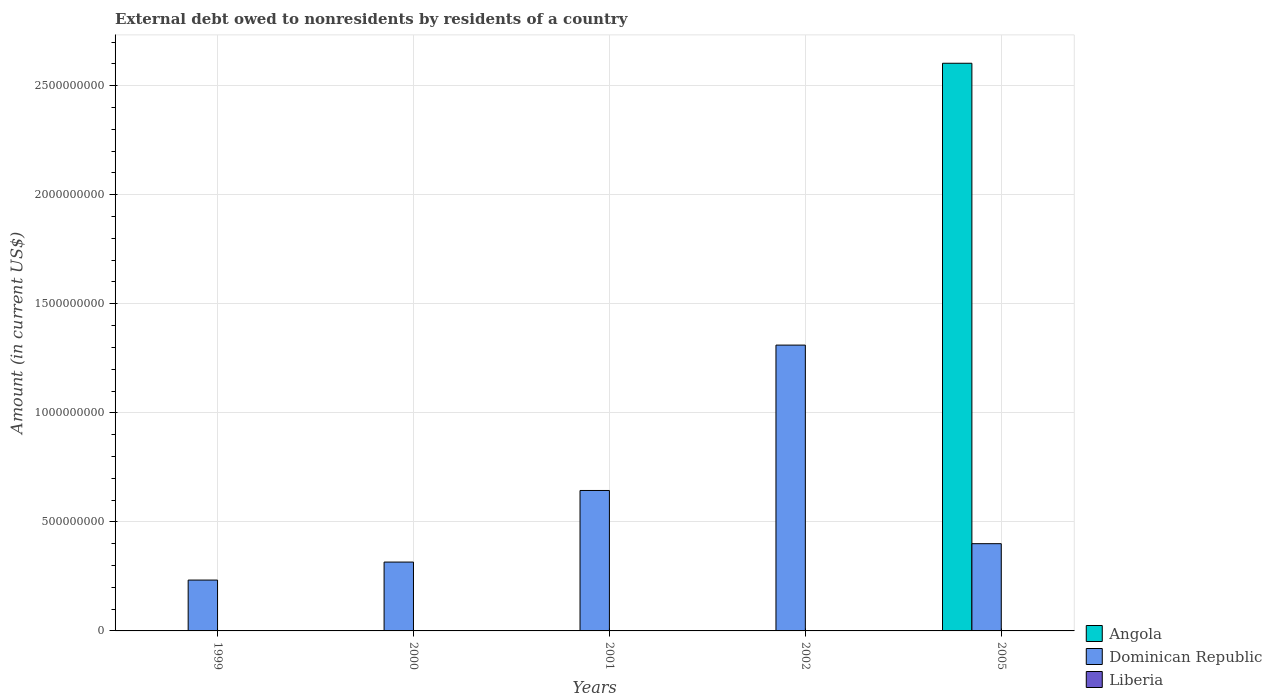How many different coloured bars are there?
Ensure brevity in your answer.  2. Are the number of bars per tick equal to the number of legend labels?
Your response must be concise. No. How many bars are there on the 5th tick from the right?
Ensure brevity in your answer.  1. In how many cases, is the number of bars for a given year not equal to the number of legend labels?
Provide a short and direct response. 5. What is the external debt owed by residents in Dominican Republic in 2005?
Your answer should be compact. 4.00e+08. Across all years, what is the maximum external debt owed by residents in Angola?
Provide a succinct answer. 2.60e+09. In which year was the external debt owed by residents in Angola maximum?
Ensure brevity in your answer.  2005. What is the total external debt owed by residents in Dominican Republic in the graph?
Offer a terse response. 2.90e+09. What is the difference between the external debt owed by residents in Dominican Republic in 1999 and that in 2000?
Give a very brief answer. -8.25e+07. What is the difference between the external debt owed by residents in Liberia in 2002 and the external debt owed by residents in Dominican Republic in 1999?
Provide a succinct answer. -2.33e+08. What is the average external debt owed by residents in Angola per year?
Your answer should be compact. 5.21e+08. In the year 2005, what is the difference between the external debt owed by residents in Dominican Republic and external debt owed by residents in Angola?
Your response must be concise. -2.20e+09. What is the ratio of the external debt owed by residents in Dominican Republic in 2000 to that in 2005?
Offer a very short reply. 0.79. What is the difference between the highest and the second highest external debt owed by residents in Dominican Republic?
Give a very brief answer. 6.67e+08. What is the difference between the highest and the lowest external debt owed by residents in Dominican Republic?
Offer a terse response. 1.08e+09. Is the sum of the external debt owed by residents in Dominican Republic in 1999 and 2002 greater than the maximum external debt owed by residents in Liberia across all years?
Ensure brevity in your answer.  Yes. Are all the bars in the graph horizontal?
Your answer should be compact. No. How many years are there in the graph?
Your response must be concise. 5. Does the graph contain grids?
Keep it short and to the point. Yes. Where does the legend appear in the graph?
Give a very brief answer. Bottom right. What is the title of the graph?
Ensure brevity in your answer.  External debt owed to nonresidents by residents of a country. What is the label or title of the X-axis?
Your response must be concise. Years. What is the label or title of the Y-axis?
Give a very brief answer. Amount (in current US$). What is the Amount (in current US$) in Angola in 1999?
Offer a very short reply. 0. What is the Amount (in current US$) of Dominican Republic in 1999?
Keep it short and to the point. 2.33e+08. What is the Amount (in current US$) in Liberia in 1999?
Make the answer very short. 0. What is the Amount (in current US$) of Dominican Republic in 2000?
Your response must be concise. 3.16e+08. What is the Amount (in current US$) of Liberia in 2000?
Your answer should be compact. 0. What is the Amount (in current US$) of Dominican Republic in 2001?
Make the answer very short. 6.44e+08. What is the Amount (in current US$) in Liberia in 2001?
Your answer should be compact. 0. What is the Amount (in current US$) in Angola in 2002?
Keep it short and to the point. 0. What is the Amount (in current US$) in Dominican Republic in 2002?
Your response must be concise. 1.31e+09. What is the Amount (in current US$) in Liberia in 2002?
Keep it short and to the point. 0. What is the Amount (in current US$) of Angola in 2005?
Keep it short and to the point. 2.60e+09. What is the Amount (in current US$) of Dominican Republic in 2005?
Offer a terse response. 4.00e+08. Across all years, what is the maximum Amount (in current US$) in Angola?
Your response must be concise. 2.60e+09. Across all years, what is the maximum Amount (in current US$) of Dominican Republic?
Offer a terse response. 1.31e+09. Across all years, what is the minimum Amount (in current US$) of Dominican Republic?
Keep it short and to the point. 2.33e+08. What is the total Amount (in current US$) of Angola in the graph?
Provide a succinct answer. 2.60e+09. What is the total Amount (in current US$) of Dominican Republic in the graph?
Make the answer very short. 2.90e+09. What is the difference between the Amount (in current US$) of Dominican Republic in 1999 and that in 2000?
Offer a terse response. -8.25e+07. What is the difference between the Amount (in current US$) of Dominican Republic in 1999 and that in 2001?
Your response must be concise. -4.11e+08. What is the difference between the Amount (in current US$) of Dominican Republic in 1999 and that in 2002?
Give a very brief answer. -1.08e+09. What is the difference between the Amount (in current US$) in Dominican Republic in 1999 and that in 2005?
Your answer should be compact. -1.67e+08. What is the difference between the Amount (in current US$) in Dominican Republic in 2000 and that in 2001?
Offer a very short reply. -3.28e+08. What is the difference between the Amount (in current US$) of Dominican Republic in 2000 and that in 2002?
Keep it short and to the point. -9.95e+08. What is the difference between the Amount (in current US$) of Dominican Republic in 2000 and that in 2005?
Offer a very short reply. -8.43e+07. What is the difference between the Amount (in current US$) of Dominican Republic in 2001 and that in 2002?
Offer a very short reply. -6.67e+08. What is the difference between the Amount (in current US$) in Dominican Republic in 2001 and that in 2005?
Provide a short and direct response. 2.44e+08. What is the difference between the Amount (in current US$) of Dominican Republic in 2002 and that in 2005?
Your answer should be compact. 9.11e+08. What is the average Amount (in current US$) in Angola per year?
Your response must be concise. 5.21e+08. What is the average Amount (in current US$) of Dominican Republic per year?
Give a very brief answer. 5.81e+08. What is the average Amount (in current US$) in Liberia per year?
Make the answer very short. 0. In the year 2005, what is the difference between the Amount (in current US$) of Angola and Amount (in current US$) of Dominican Republic?
Offer a very short reply. 2.20e+09. What is the ratio of the Amount (in current US$) of Dominican Republic in 1999 to that in 2000?
Offer a very short reply. 0.74. What is the ratio of the Amount (in current US$) in Dominican Republic in 1999 to that in 2001?
Make the answer very short. 0.36. What is the ratio of the Amount (in current US$) of Dominican Republic in 1999 to that in 2002?
Your answer should be compact. 0.18. What is the ratio of the Amount (in current US$) in Dominican Republic in 1999 to that in 2005?
Your response must be concise. 0.58. What is the ratio of the Amount (in current US$) in Dominican Republic in 2000 to that in 2001?
Keep it short and to the point. 0.49. What is the ratio of the Amount (in current US$) of Dominican Republic in 2000 to that in 2002?
Provide a short and direct response. 0.24. What is the ratio of the Amount (in current US$) in Dominican Republic in 2000 to that in 2005?
Provide a succinct answer. 0.79. What is the ratio of the Amount (in current US$) of Dominican Republic in 2001 to that in 2002?
Make the answer very short. 0.49. What is the ratio of the Amount (in current US$) in Dominican Republic in 2001 to that in 2005?
Provide a short and direct response. 1.61. What is the ratio of the Amount (in current US$) of Dominican Republic in 2002 to that in 2005?
Your response must be concise. 3.28. What is the difference between the highest and the second highest Amount (in current US$) in Dominican Republic?
Give a very brief answer. 6.67e+08. What is the difference between the highest and the lowest Amount (in current US$) of Angola?
Offer a very short reply. 2.60e+09. What is the difference between the highest and the lowest Amount (in current US$) in Dominican Republic?
Provide a succinct answer. 1.08e+09. 